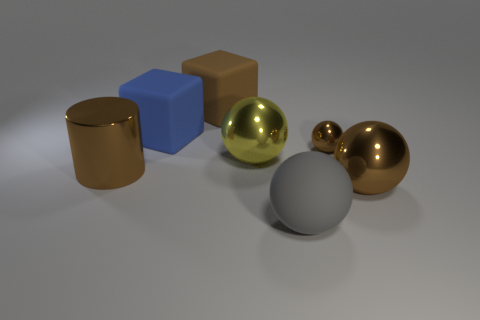Add 2 big yellow metallic blocks. How many objects exist? 9 Subtract all blocks. How many objects are left? 5 Subtract all gray objects. Subtract all big brown metal things. How many objects are left? 4 Add 4 big rubber balls. How many big rubber balls are left? 5 Add 4 blue balls. How many blue balls exist? 4 Subtract 0 blue balls. How many objects are left? 7 